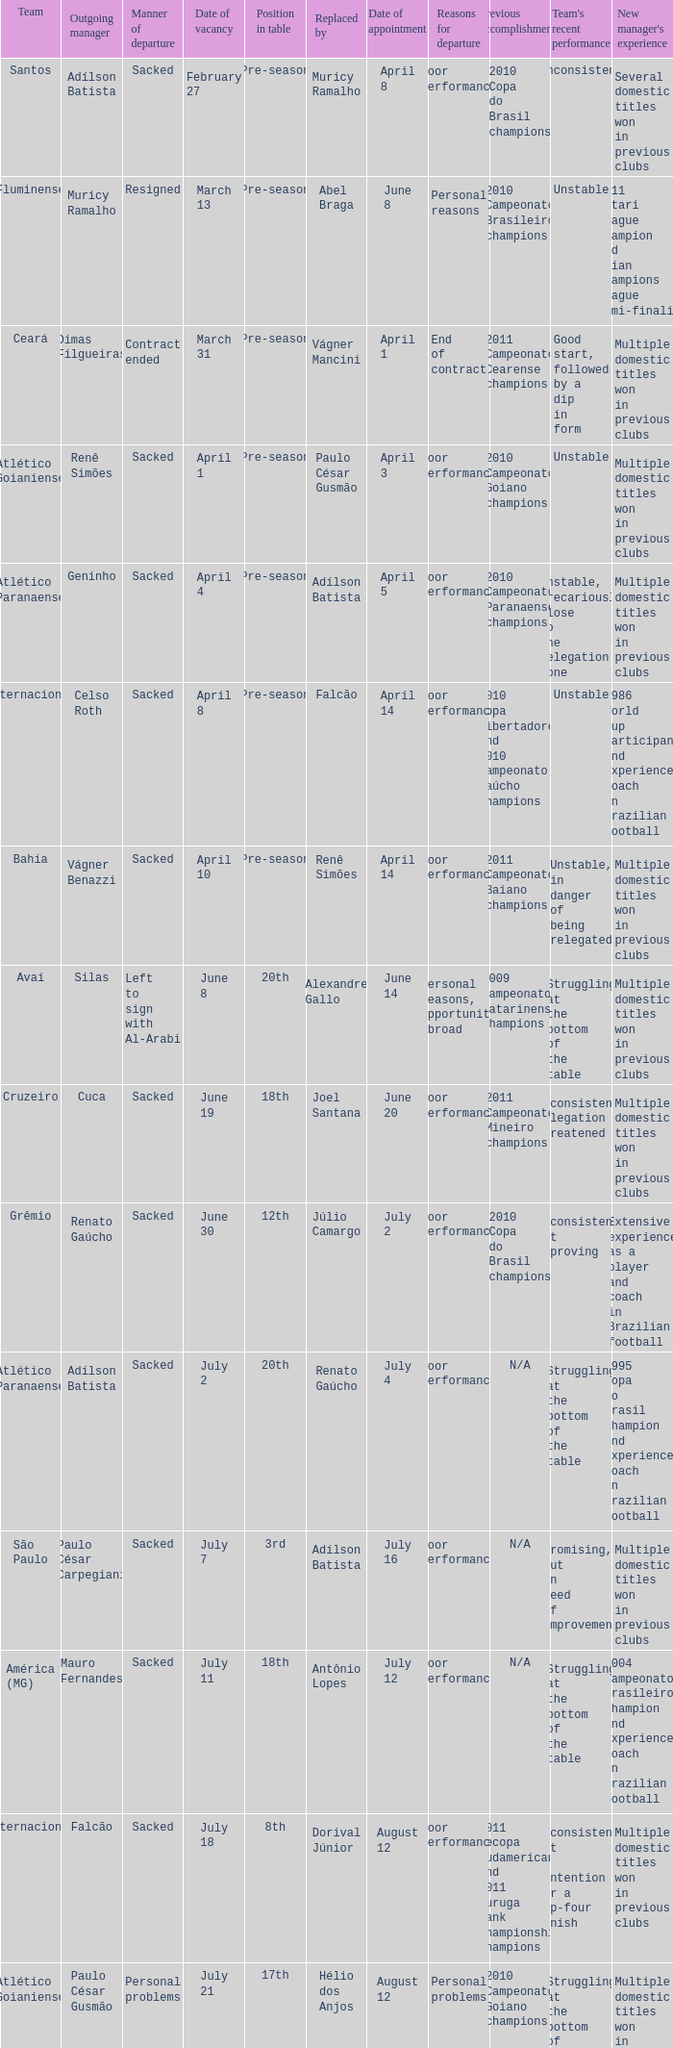What team hired Renato Gaúcho? Atlético Paranaense. 